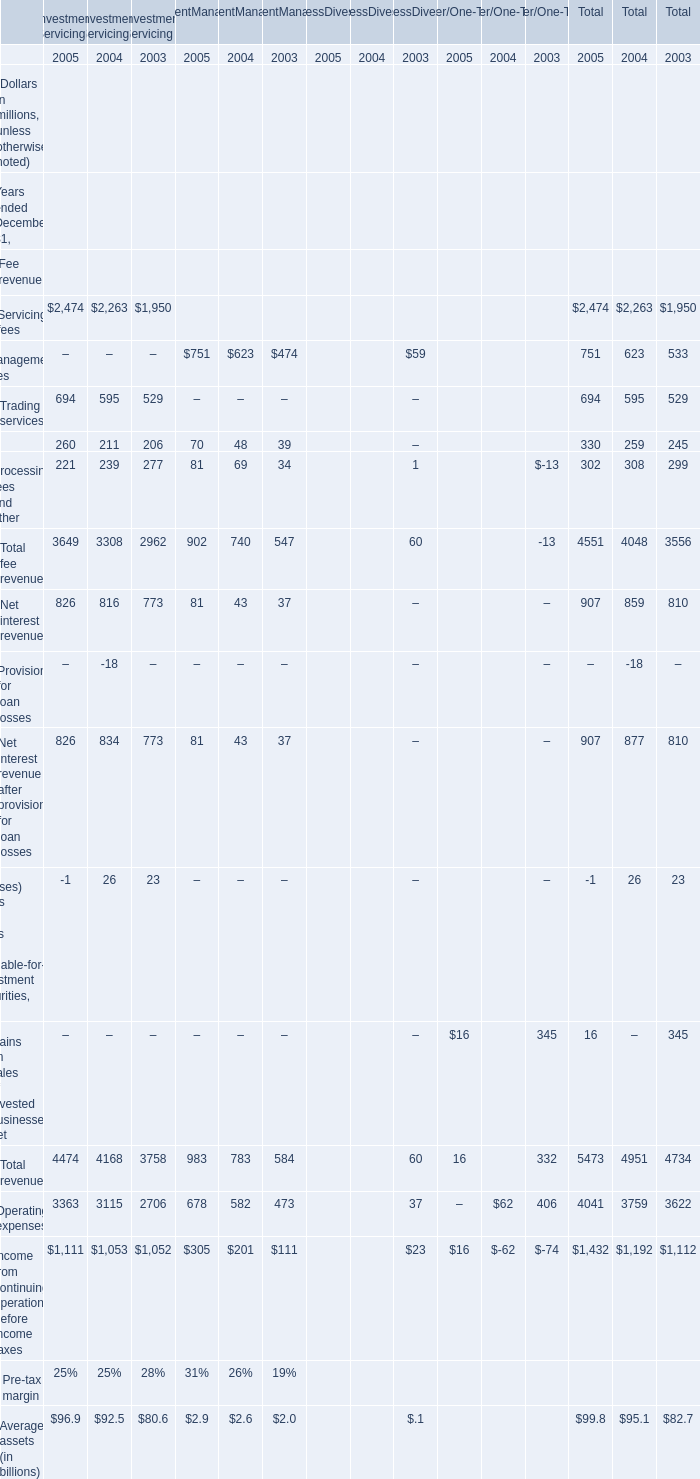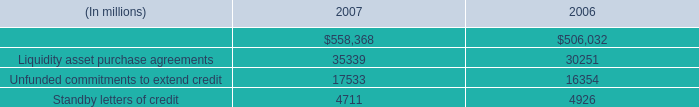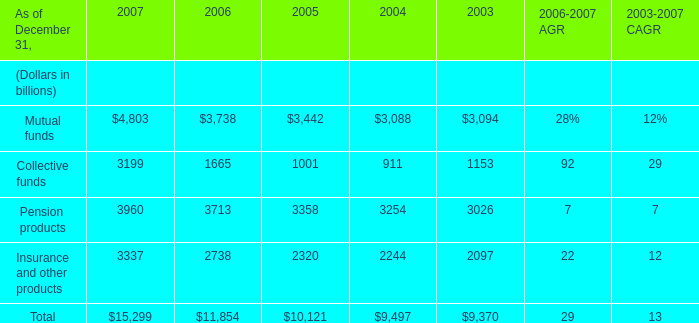what is the percentage change in the the balance of cash and u.s . government securities from 2006 to 2007? 
Computations: ((572.93 - 527.37) / 527.37)
Answer: 0.08639. 